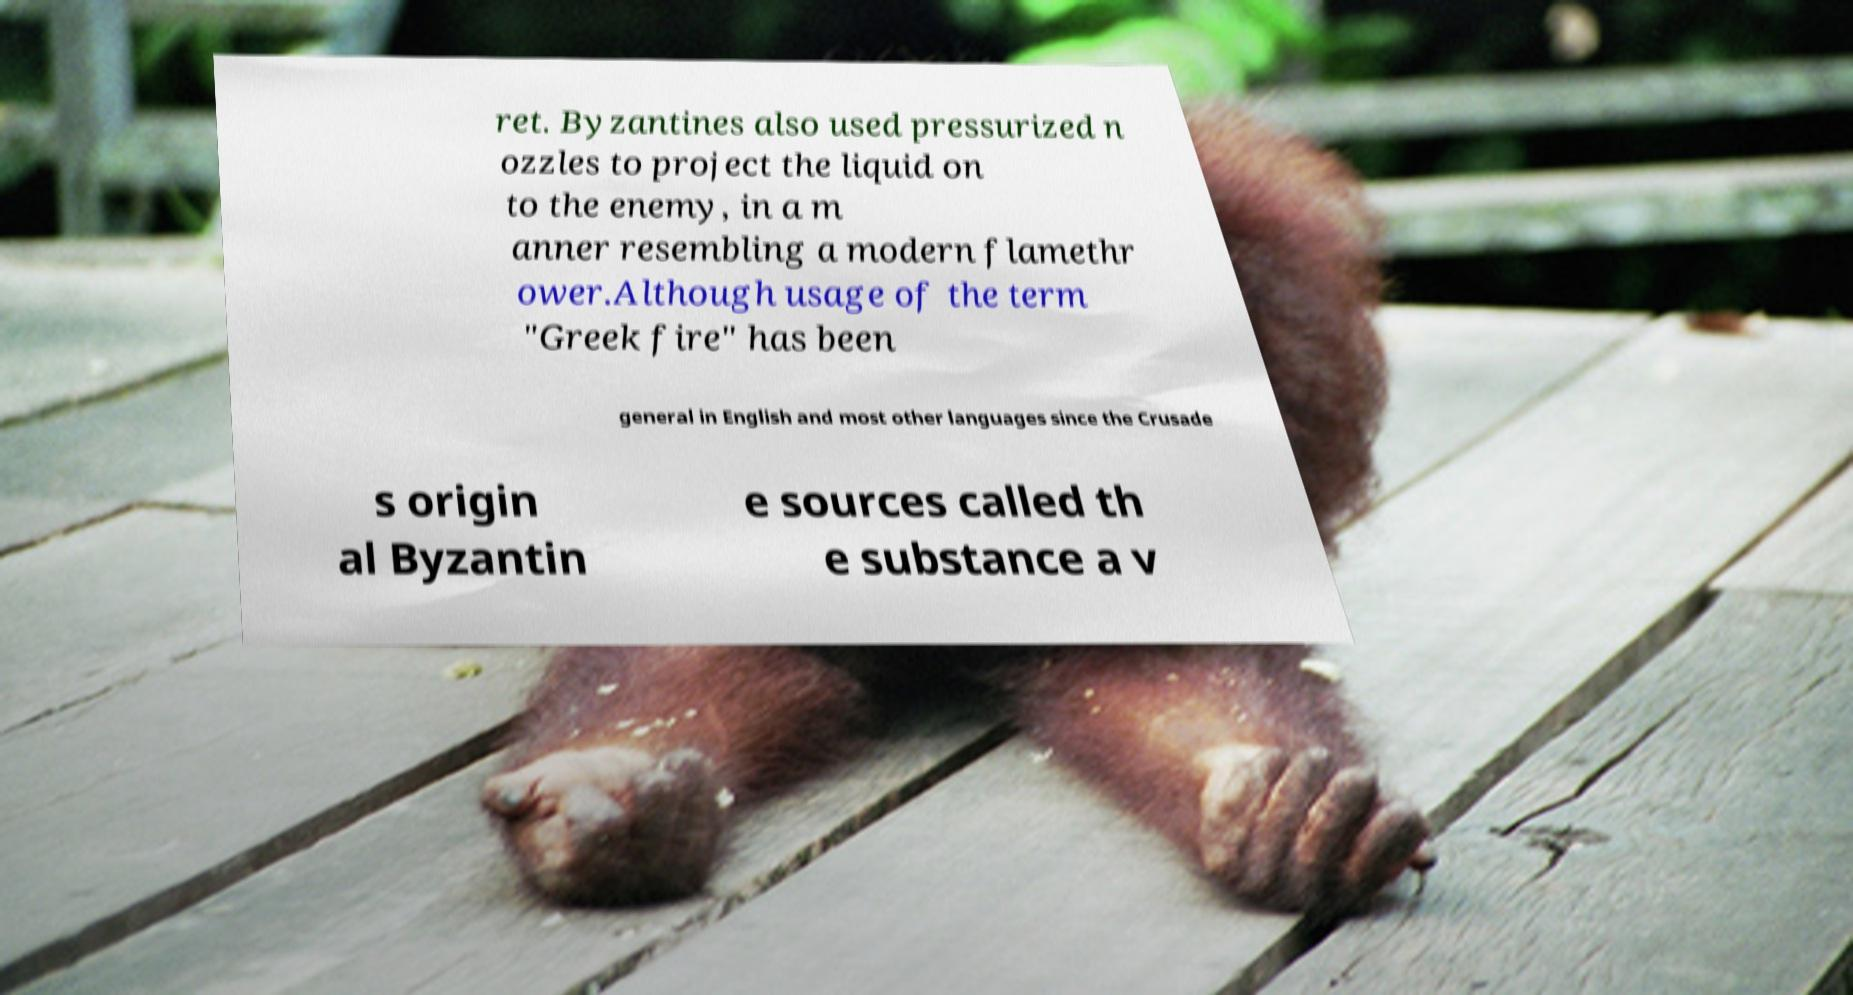Can you accurately transcribe the text from the provided image for me? ret. Byzantines also used pressurized n ozzles to project the liquid on to the enemy, in a m anner resembling a modern flamethr ower.Although usage of the term "Greek fire" has been general in English and most other languages since the Crusade s origin al Byzantin e sources called th e substance a v 